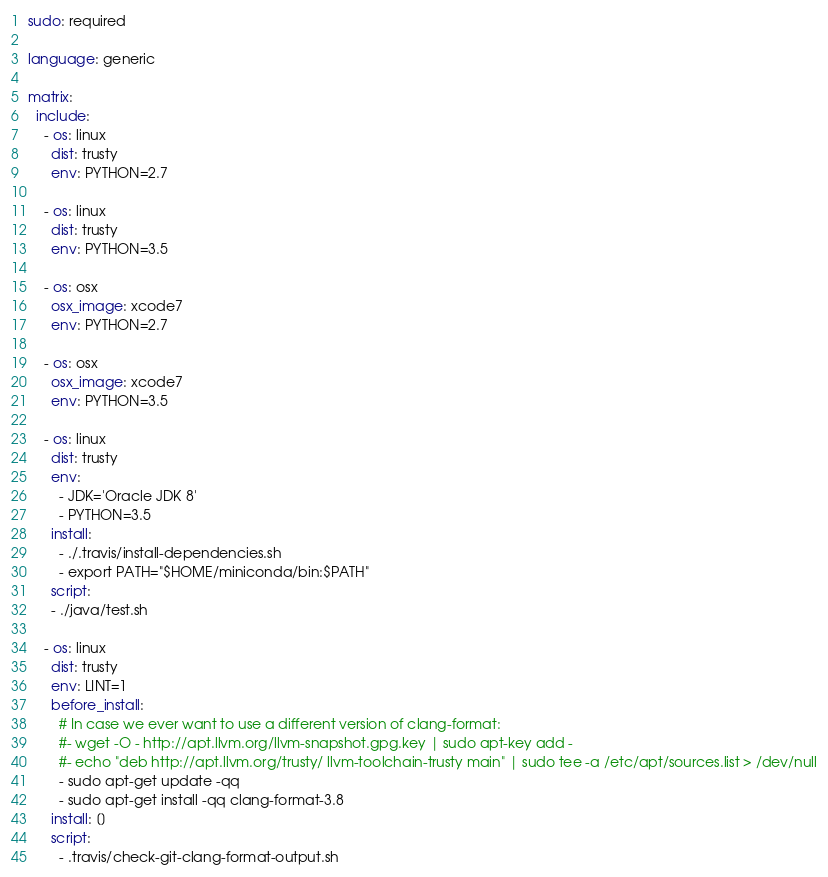<code> <loc_0><loc_0><loc_500><loc_500><_YAML_>sudo: required

language: generic

matrix:
  include:
    - os: linux
      dist: trusty
      env: PYTHON=2.7

    - os: linux
      dist: trusty
      env: PYTHON=3.5

    - os: osx
      osx_image: xcode7
      env: PYTHON=2.7

    - os: osx
      osx_image: xcode7
      env: PYTHON=3.5

    - os: linux
      dist: trusty
      env:
        - JDK='Oracle JDK 8'
        - PYTHON=3.5
      install:
        - ./.travis/install-dependencies.sh
        - export PATH="$HOME/miniconda/bin:$PATH"
      script:
      - ./java/test.sh

    - os: linux
      dist: trusty
      env: LINT=1
      before_install:
        # In case we ever want to use a different version of clang-format:
        #- wget -O - http://apt.llvm.org/llvm-snapshot.gpg.key | sudo apt-key add -
        #- echo "deb http://apt.llvm.org/trusty/ llvm-toolchain-trusty main" | sudo tee -a /etc/apt/sources.list > /dev/null
        - sudo apt-get update -qq
        - sudo apt-get install -qq clang-format-3.8
      install: []
      script:
        - .travis/check-git-clang-format-output.sh</code> 